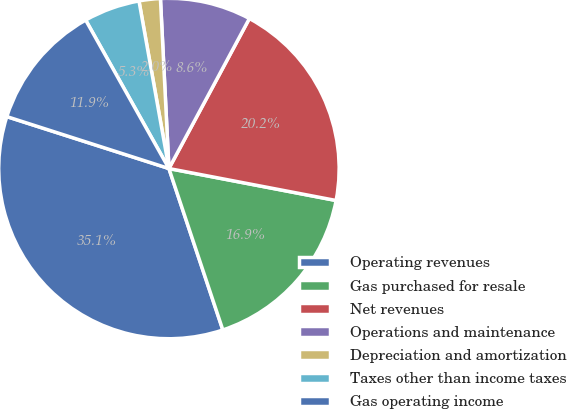Convert chart. <chart><loc_0><loc_0><loc_500><loc_500><pie_chart><fcel>Operating revenues<fcel>Gas purchased for resale<fcel>Net revenues<fcel>Operations and maintenance<fcel>Depreciation and amortization<fcel>Taxes other than income taxes<fcel>Gas operating income<nl><fcel>35.06%<fcel>16.86%<fcel>20.17%<fcel>8.63%<fcel>2.02%<fcel>5.32%<fcel>11.93%<nl></chart> 